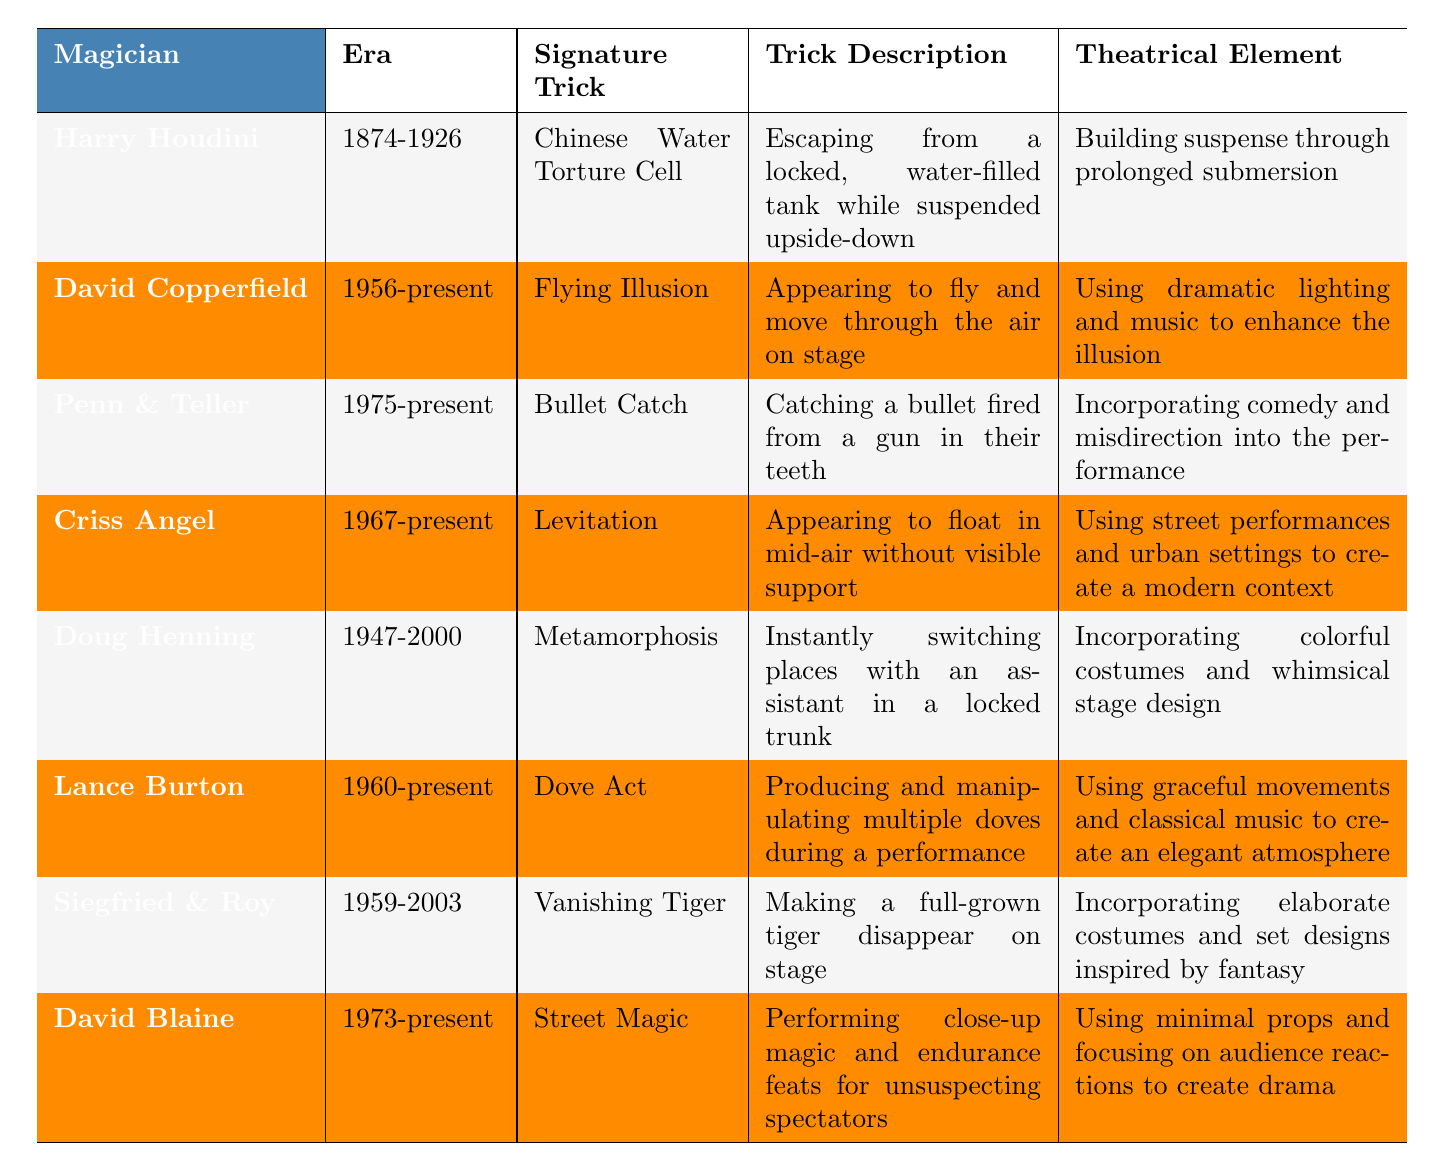What is the signature trick of Harry Houdini? According to the table, Harry Houdini's signature trick is the "Chinese Water Torture Cell."
Answer: Chinese Water Torture Cell In which era did Doug Henning perform? The table shows that Doug Henning performed during the era of 1947-2000.
Answer: 1947-2000 Who is known for the "Bullet Catch" trick? The table indicates that the "Bullet Catch" trick is performed by Penn & Teller.
Answer: Penn & Teller What theatrical element is associated with David Blaine's performances? The table states that David Blaine's theatrical element involves using minimal props and focusing on audience reactions to create drama.
Answer: Minimal props and audience reactions Is Criss Angel known for a water trick? The table does not list any water tricks associated with Criss Angel; instead, he is known for "Levitation."
Answer: No Which magician's trick involves classic music to create an elegant atmosphere? According to the table, Lance Burton's "Dove Act" incorporates graceful movements and classical music for an elegant feel.
Answer: Lance Burton How many magicians mentioned in the table have performed during the era of 1960-present? The table lists three magicians from the era of 1960-present: Criss Angel, Lance Burton, and David Copperfield. Therefore, the total is 3.
Answer: 3 Which magician's signature trick involves transforming or switching places? The signature trick involving transformation is "Metamorphosis," performed by Doug Henning.
Answer: Doug Henning What is the trick description of the "Vanishing Tiger"? The table describes the "Vanishing Tiger" as making a full-grown tiger disappear on stage.
Answer: Making a full-grown tiger disappear Are there any magicians known for comedy in their performances? The table states that Penn & Teller are known for incorporating comedy and misdirection into their performances.
Answer: Yes Which magician's signature trick has the longest description? By comparing the trick descriptions in the table, "Catching a bullet fired from a gun in their teeth" for Penn & Teller is the longest.
Answer: Penn & Teller 